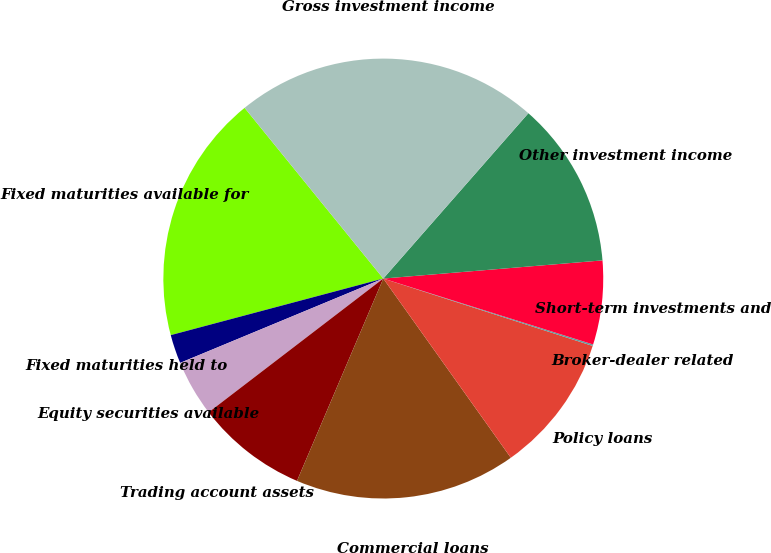Convert chart. <chart><loc_0><loc_0><loc_500><loc_500><pie_chart><fcel>Fixed maturities available for<fcel>Fixed maturities held to<fcel>Equity securities available<fcel>Trading account assets<fcel>Commercial loans<fcel>Policy loans<fcel>Broker-dealer related<fcel>Short-term investments and<fcel>Other investment income<fcel>Gross investment income<nl><fcel>18.28%<fcel>2.12%<fcel>4.14%<fcel>8.18%<fcel>16.26%<fcel>10.2%<fcel>0.11%<fcel>6.16%<fcel>12.22%<fcel>22.32%<nl></chart> 